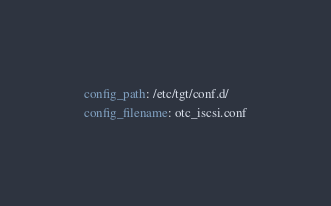Convert code to text. <code><loc_0><loc_0><loc_500><loc_500><_YAML_>config_path: /etc/tgt/conf.d/
config_filename: otc_iscsi.conf
</code> 